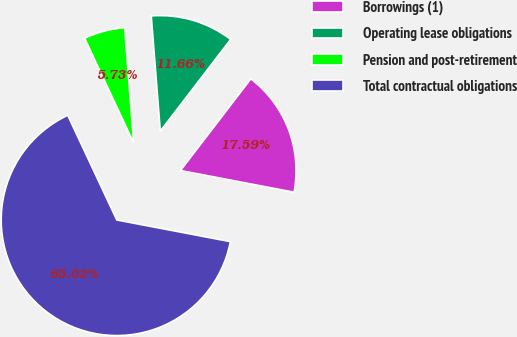<chart> <loc_0><loc_0><loc_500><loc_500><pie_chart><fcel>Borrowings (1)<fcel>Operating lease obligations<fcel>Pension and post-retirement<fcel>Total contractual obligations<nl><fcel>17.59%<fcel>11.66%<fcel>5.73%<fcel>65.02%<nl></chart> 